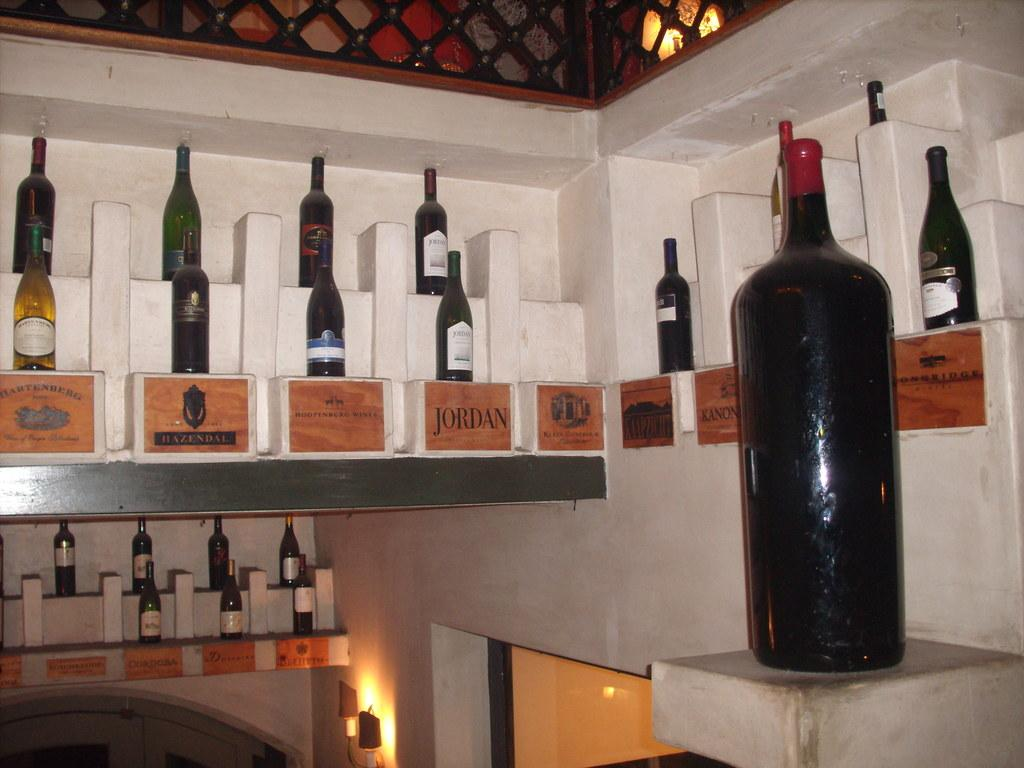What objects are present in the image? There are bottles in the image. How are the bottles positioned in the image? The back side of the bottles is visible. What is located at the bottom of the bottles? There is a printed plate on the bottom of the bottles. What information does the printed plate provide? The printed plate describes the bottle. What type of canvas is used to create the nose of the bottle in the image? There is no nose or canvas present in the image; it features bottles with printed plates on the bottom. 